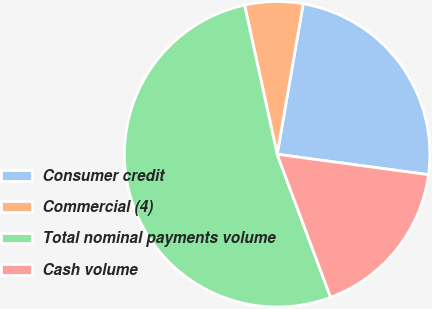<chart> <loc_0><loc_0><loc_500><loc_500><pie_chart><fcel>Consumer credit<fcel>Commercial (4)<fcel>Total nominal payments volume<fcel>Cash volume<nl><fcel>24.41%<fcel>6.15%<fcel>52.26%<fcel>17.18%<nl></chart> 